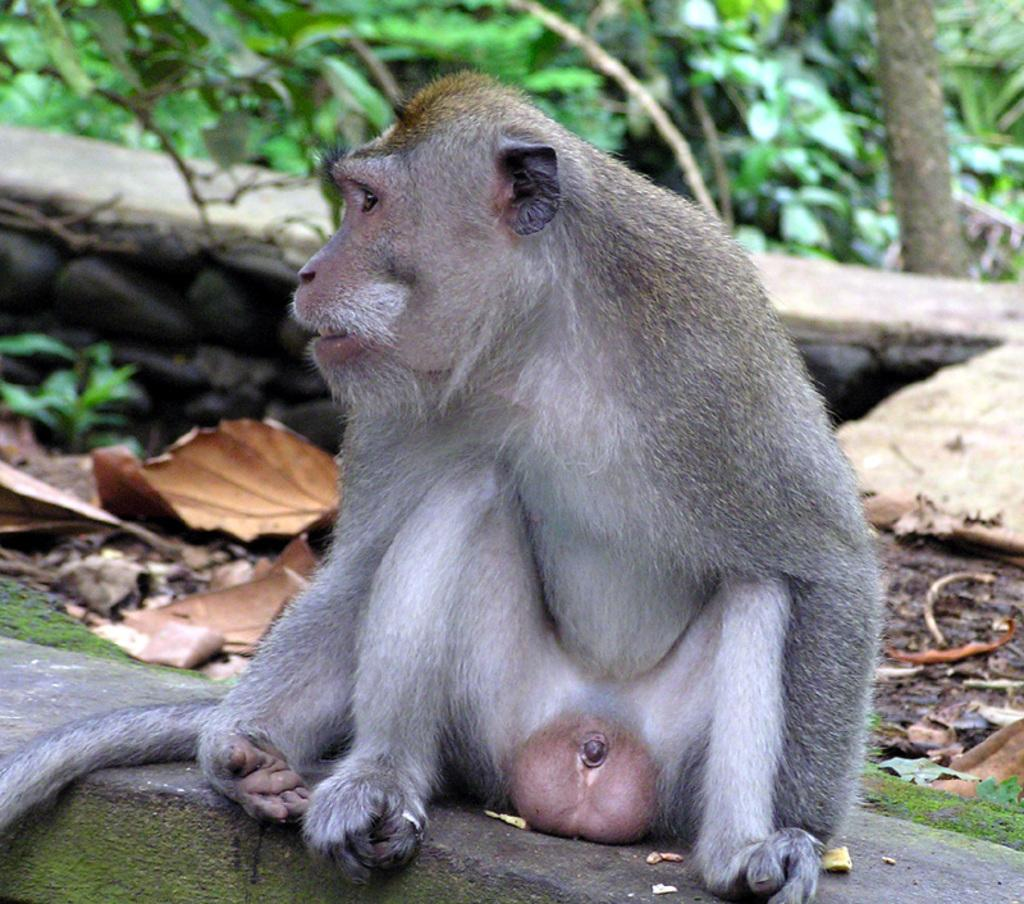What animal can be seen in the picture? There is a monkey in the picture. Where is the monkey located in the image? The monkey is sitting on a wall. What type of vegetation is visible in the image? There are many leaves visible in the image, and trees and plants are present at the top of the image. What type of leather is visible on the roof in the image? There is no roof or leather present in the image; it features a monkey sitting on a wall surrounded by vegetation. 